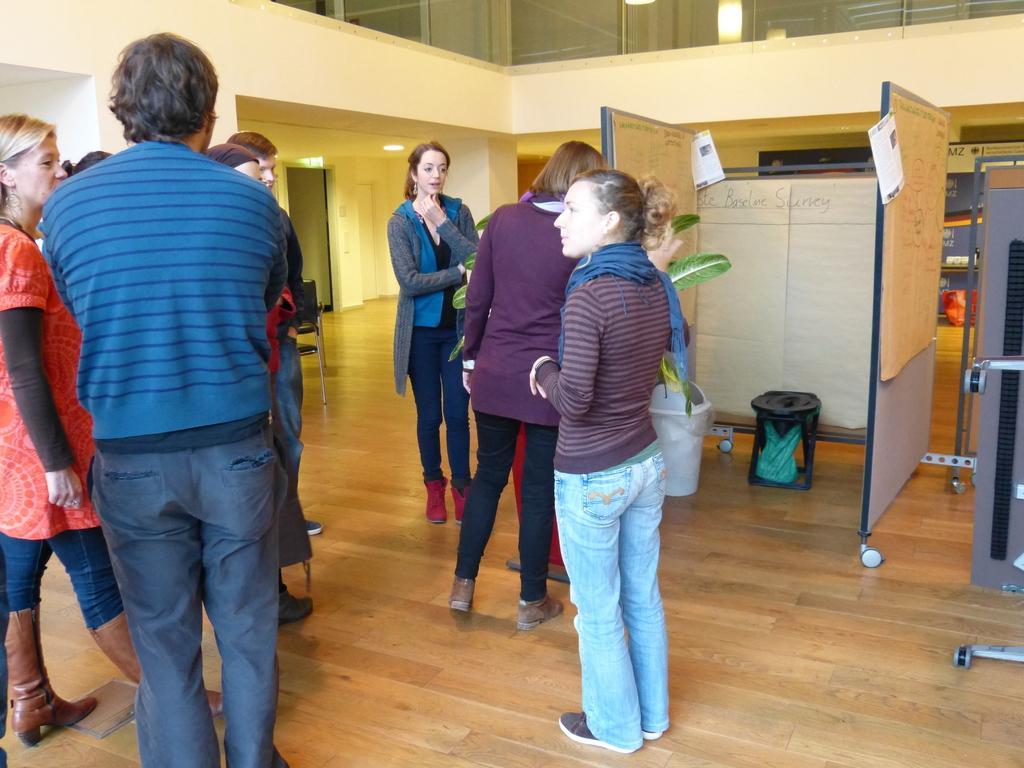Please provide a concise description of this image. In this image, we can see people standing and in the background, there are boards, papers, bins, stands, lights, windows and there is a wall. At the bottom, there is floor. 